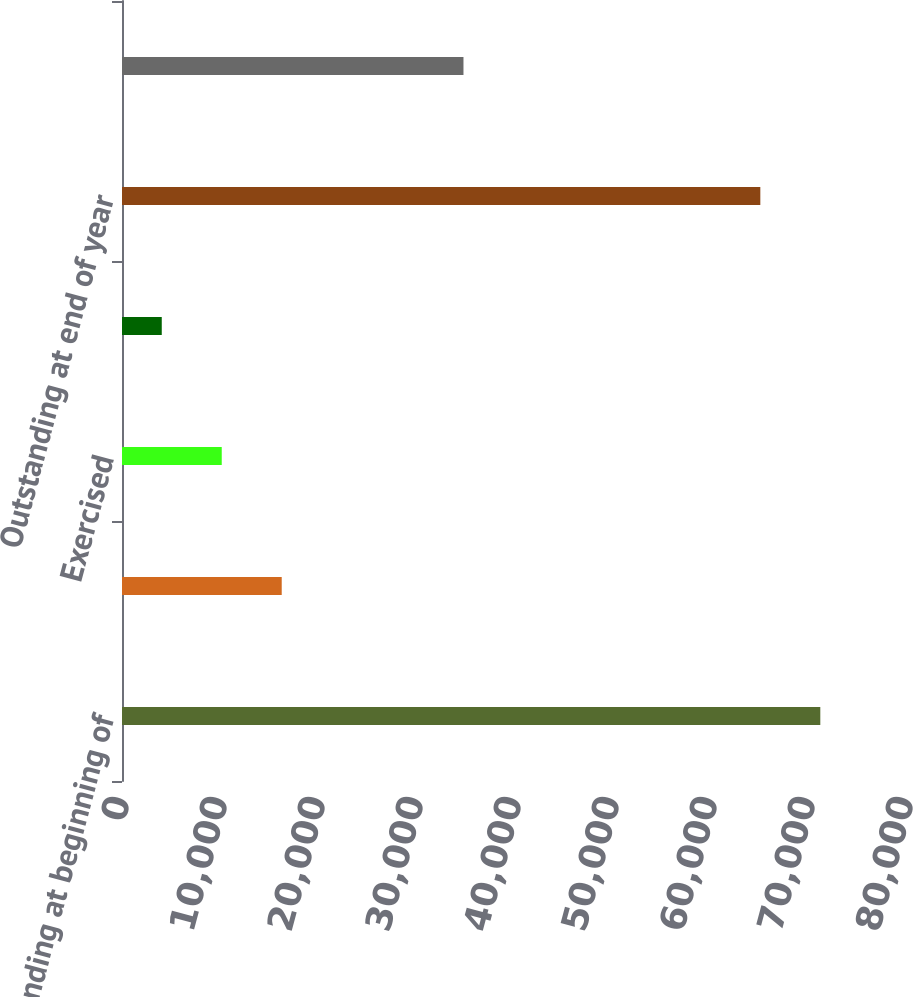Convert chart. <chart><loc_0><loc_0><loc_500><loc_500><bar_chart><fcel>Outstanding at beginning of<fcel>Granted<fcel>Exercised<fcel>Forfeited<fcel>Outstanding at end of year<fcel>Exercisable at end of year<nl><fcel>71255.6<fcel>16298.2<fcel>10177.6<fcel>4057<fcel>65135<fcel>34844<nl></chart> 